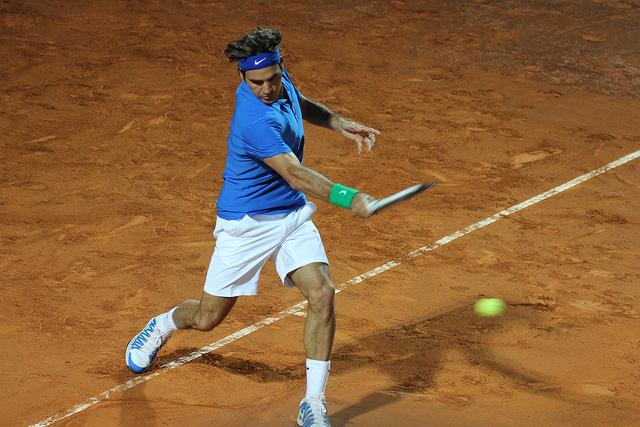How is he standing?
Concise answer only. Crooked. What is the court composed of?
Be succinct. Clay. Why is the player wearing a headband?
Concise answer only. Sweat. Is the tennis ball in the player's hand?
Concise answer only. No. What type of surface is the court?
Keep it brief. Dirt. 